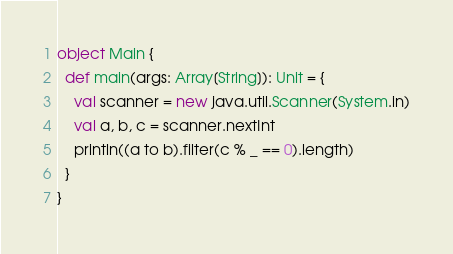Convert code to text. <code><loc_0><loc_0><loc_500><loc_500><_Scala_>object Main {
  def main(args: Array[String]): Unit = {
    val scanner = new java.util.Scanner(System.in)
    val a, b, c = scanner.nextInt
    println((a to b).filter(c % _ == 0).length)
  }
}
</code> 